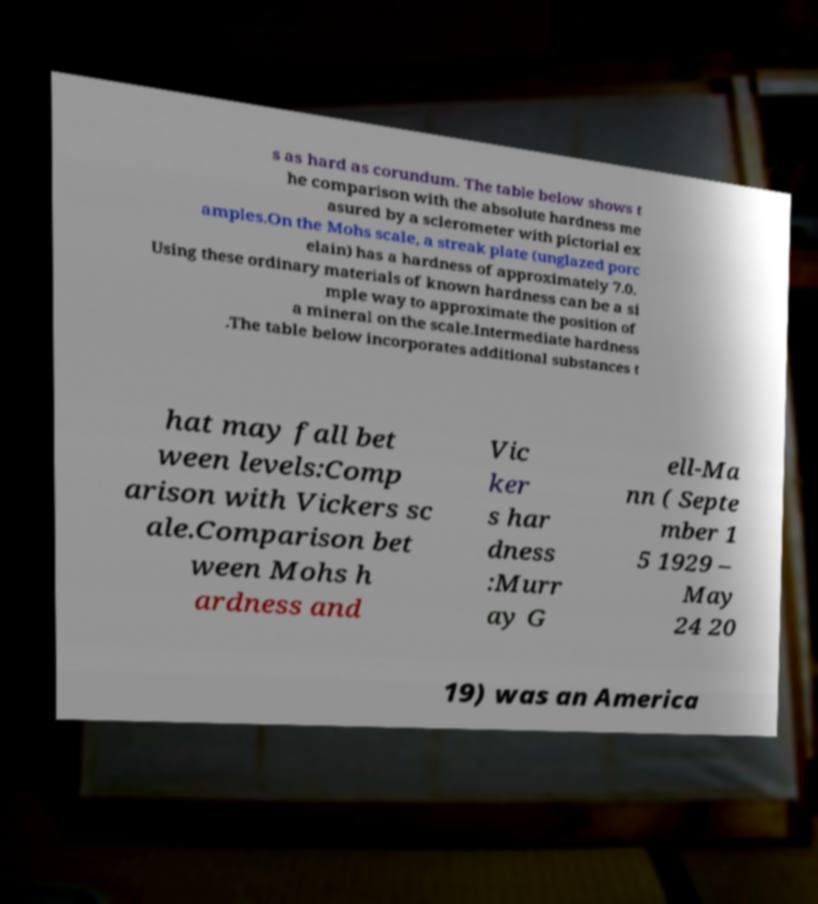Please identify and transcribe the text found in this image. s as hard as corundum. The table below shows t he comparison with the absolute hardness me asured by a sclerometer with pictorial ex amples.On the Mohs scale, a streak plate (unglazed porc elain) has a hardness of approximately 7.0. Using these ordinary materials of known hardness can be a si mple way to approximate the position of a mineral on the scale.Intermediate hardness .The table below incorporates additional substances t hat may fall bet ween levels:Comp arison with Vickers sc ale.Comparison bet ween Mohs h ardness and Vic ker s har dness :Murr ay G ell-Ma nn ( Septe mber 1 5 1929 – May 24 20 19) was an America 